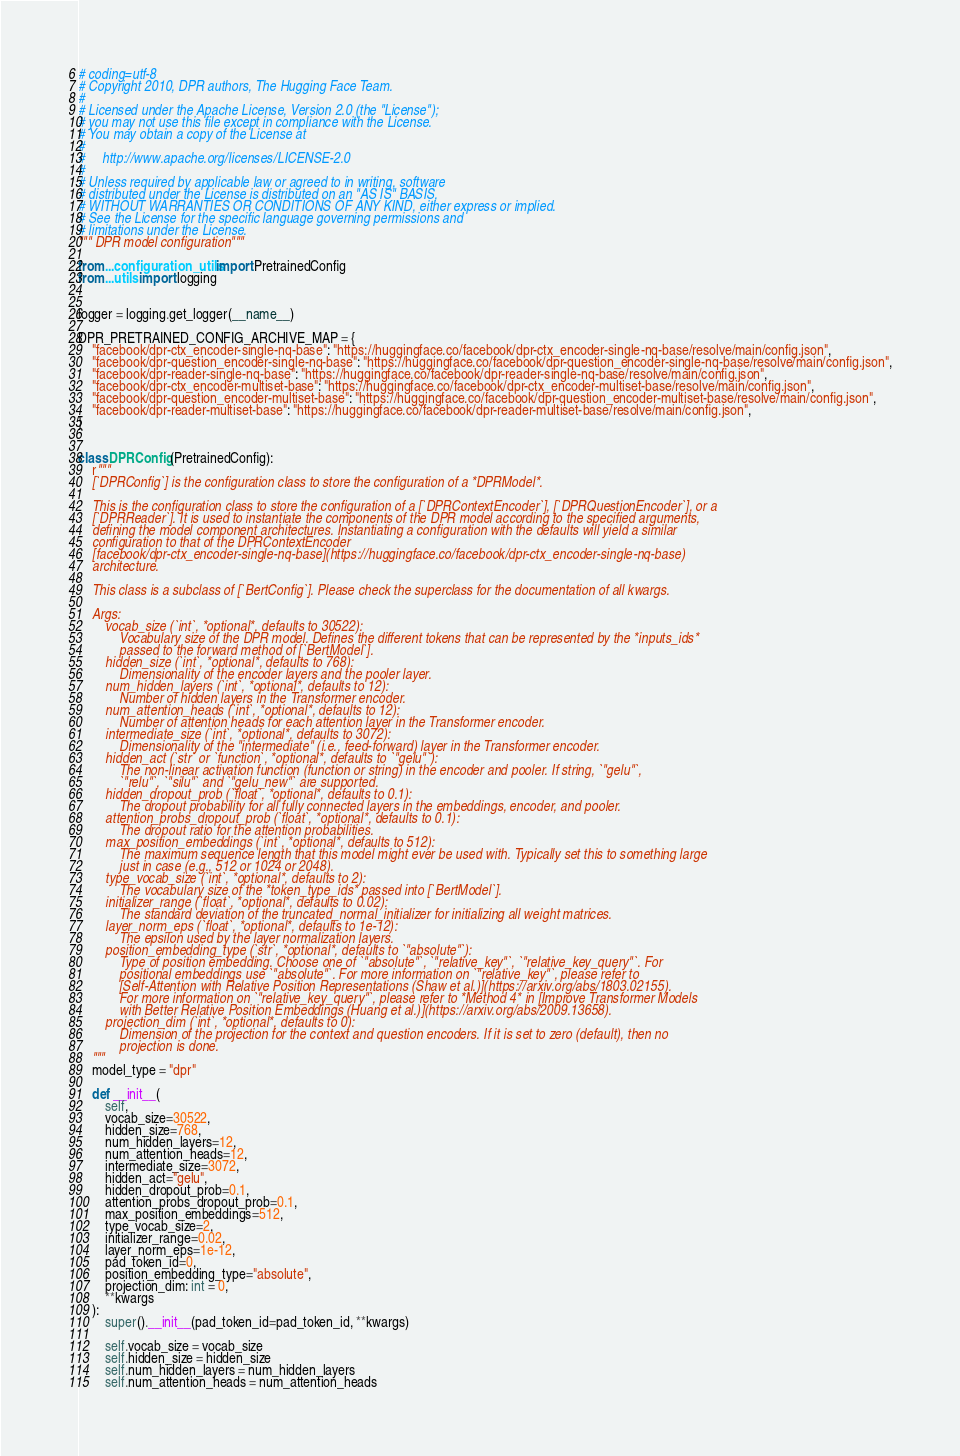Convert code to text. <code><loc_0><loc_0><loc_500><loc_500><_Python_># coding=utf-8
# Copyright 2010, DPR authors, The Hugging Face Team.
#
# Licensed under the Apache License, Version 2.0 (the "License");
# you may not use this file except in compliance with the License.
# You may obtain a copy of the License at
#
#     http://www.apache.org/licenses/LICENSE-2.0
#
# Unless required by applicable law or agreed to in writing, software
# distributed under the License is distributed on an "AS IS" BASIS,
# WITHOUT WARRANTIES OR CONDITIONS OF ANY KIND, either express or implied.
# See the License for the specific language governing permissions and
# limitations under the License.
""" DPR model configuration"""

from ...configuration_utils import PretrainedConfig
from ...utils import logging


logger = logging.get_logger(__name__)

DPR_PRETRAINED_CONFIG_ARCHIVE_MAP = {
    "facebook/dpr-ctx_encoder-single-nq-base": "https://huggingface.co/facebook/dpr-ctx_encoder-single-nq-base/resolve/main/config.json",
    "facebook/dpr-question_encoder-single-nq-base": "https://huggingface.co/facebook/dpr-question_encoder-single-nq-base/resolve/main/config.json",
    "facebook/dpr-reader-single-nq-base": "https://huggingface.co/facebook/dpr-reader-single-nq-base/resolve/main/config.json",
    "facebook/dpr-ctx_encoder-multiset-base": "https://huggingface.co/facebook/dpr-ctx_encoder-multiset-base/resolve/main/config.json",
    "facebook/dpr-question_encoder-multiset-base": "https://huggingface.co/facebook/dpr-question_encoder-multiset-base/resolve/main/config.json",
    "facebook/dpr-reader-multiset-base": "https://huggingface.co/facebook/dpr-reader-multiset-base/resolve/main/config.json",
}


class DPRConfig(PretrainedConfig):
    r"""
    [`DPRConfig`] is the configuration class to store the configuration of a *DPRModel*.

    This is the configuration class to store the configuration of a [`DPRContextEncoder`], [`DPRQuestionEncoder`], or a
    [`DPRReader`]. It is used to instantiate the components of the DPR model according to the specified arguments,
    defining the model component architectures. Instantiating a configuration with the defaults will yield a similar
    configuration to that of the DPRContextEncoder
    [facebook/dpr-ctx_encoder-single-nq-base](https://huggingface.co/facebook/dpr-ctx_encoder-single-nq-base)
    architecture.

    This class is a subclass of [`BertConfig`]. Please check the superclass for the documentation of all kwargs.

    Args:
        vocab_size (`int`, *optional*, defaults to 30522):
            Vocabulary size of the DPR model. Defines the different tokens that can be represented by the *inputs_ids*
            passed to the forward method of [`BertModel`].
        hidden_size (`int`, *optional*, defaults to 768):
            Dimensionality of the encoder layers and the pooler layer.
        num_hidden_layers (`int`, *optional*, defaults to 12):
            Number of hidden layers in the Transformer encoder.
        num_attention_heads (`int`, *optional*, defaults to 12):
            Number of attention heads for each attention layer in the Transformer encoder.
        intermediate_size (`int`, *optional*, defaults to 3072):
            Dimensionality of the "intermediate" (i.e., feed-forward) layer in the Transformer encoder.
        hidden_act (`str` or `function`, *optional*, defaults to `"gelu"`):
            The non-linear activation function (function or string) in the encoder and pooler. If string, `"gelu"`,
            `"relu"`, `"silu"` and `"gelu_new"` are supported.
        hidden_dropout_prob (`float`, *optional*, defaults to 0.1):
            The dropout probability for all fully connected layers in the embeddings, encoder, and pooler.
        attention_probs_dropout_prob (`float`, *optional*, defaults to 0.1):
            The dropout ratio for the attention probabilities.
        max_position_embeddings (`int`, *optional*, defaults to 512):
            The maximum sequence length that this model might ever be used with. Typically set this to something large
            just in case (e.g., 512 or 1024 or 2048).
        type_vocab_size (`int`, *optional*, defaults to 2):
            The vocabulary size of the *token_type_ids* passed into [`BertModel`].
        initializer_range (`float`, *optional*, defaults to 0.02):
            The standard deviation of the truncated_normal_initializer for initializing all weight matrices.
        layer_norm_eps (`float`, *optional*, defaults to 1e-12):
            The epsilon used by the layer normalization layers.
        position_embedding_type (`str`, *optional*, defaults to `"absolute"`):
            Type of position embedding. Choose one of `"absolute"`, `"relative_key"`, `"relative_key_query"`. For
            positional embeddings use `"absolute"`. For more information on `"relative_key"`, please refer to
            [Self-Attention with Relative Position Representations (Shaw et al.)](https://arxiv.org/abs/1803.02155).
            For more information on `"relative_key_query"`, please refer to *Method 4* in [Improve Transformer Models
            with Better Relative Position Embeddings (Huang et al.)](https://arxiv.org/abs/2009.13658).
        projection_dim (`int`, *optional*, defaults to 0):
            Dimension of the projection for the context and question encoders. If it is set to zero (default), then no
            projection is done.
    """
    model_type = "dpr"

    def __init__(
        self,
        vocab_size=30522,
        hidden_size=768,
        num_hidden_layers=12,
        num_attention_heads=12,
        intermediate_size=3072,
        hidden_act="gelu",
        hidden_dropout_prob=0.1,
        attention_probs_dropout_prob=0.1,
        max_position_embeddings=512,
        type_vocab_size=2,
        initializer_range=0.02,
        layer_norm_eps=1e-12,
        pad_token_id=0,
        position_embedding_type="absolute",
        projection_dim: int = 0,
        **kwargs
    ):
        super().__init__(pad_token_id=pad_token_id, **kwargs)

        self.vocab_size = vocab_size
        self.hidden_size = hidden_size
        self.num_hidden_layers = num_hidden_layers
        self.num_attention_heads = num_attention_heads</code> 